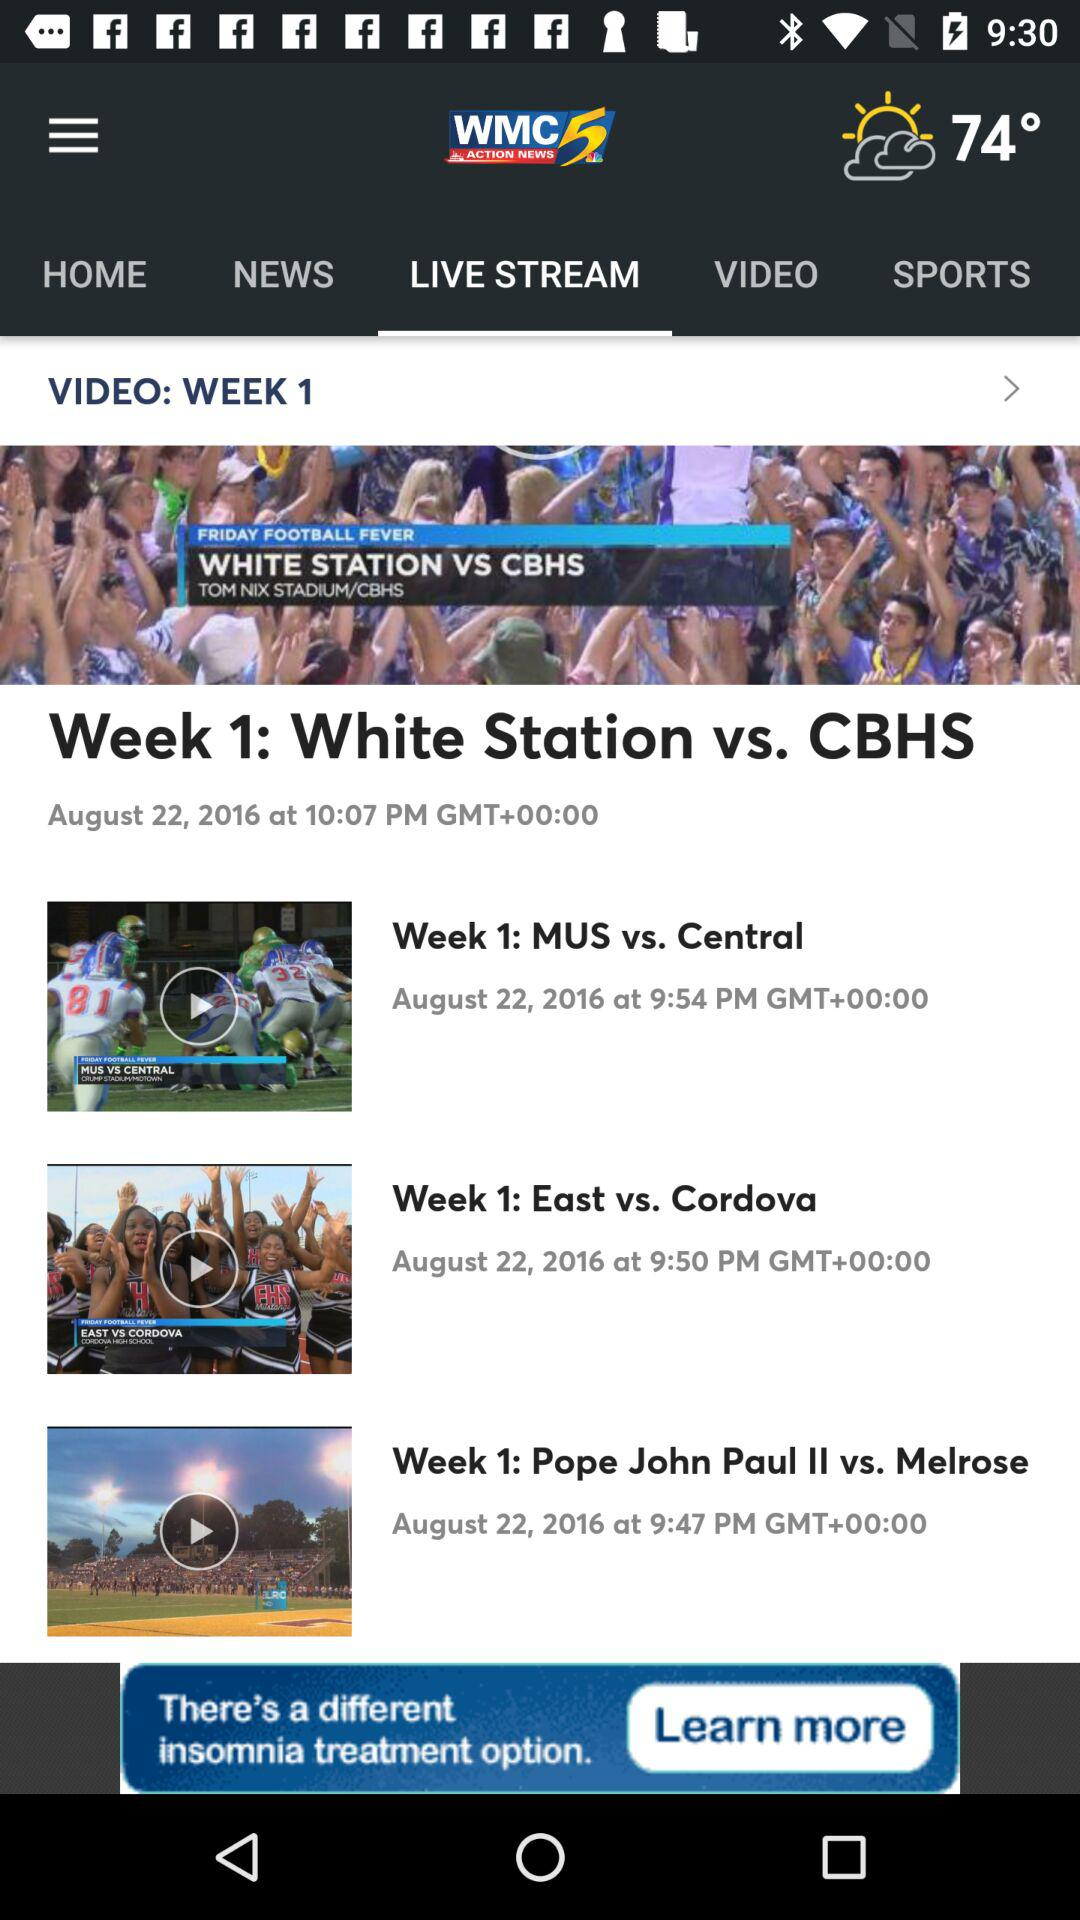Whose game is it at 9:47 p.m.? The game at 9:47 p.m. is between "Pope John Paul II" and "Melrose". 